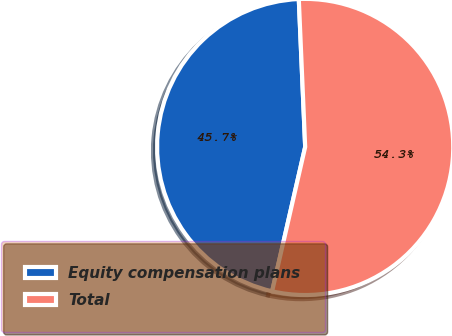Convert chart. <chart><loc_0><loc_0><loc_500><loc_500><pie_chart><fcel>Equity compensation plans<fcel>Total<nl><fcel>45.73%<fcel>54.27%<nl></chart> 